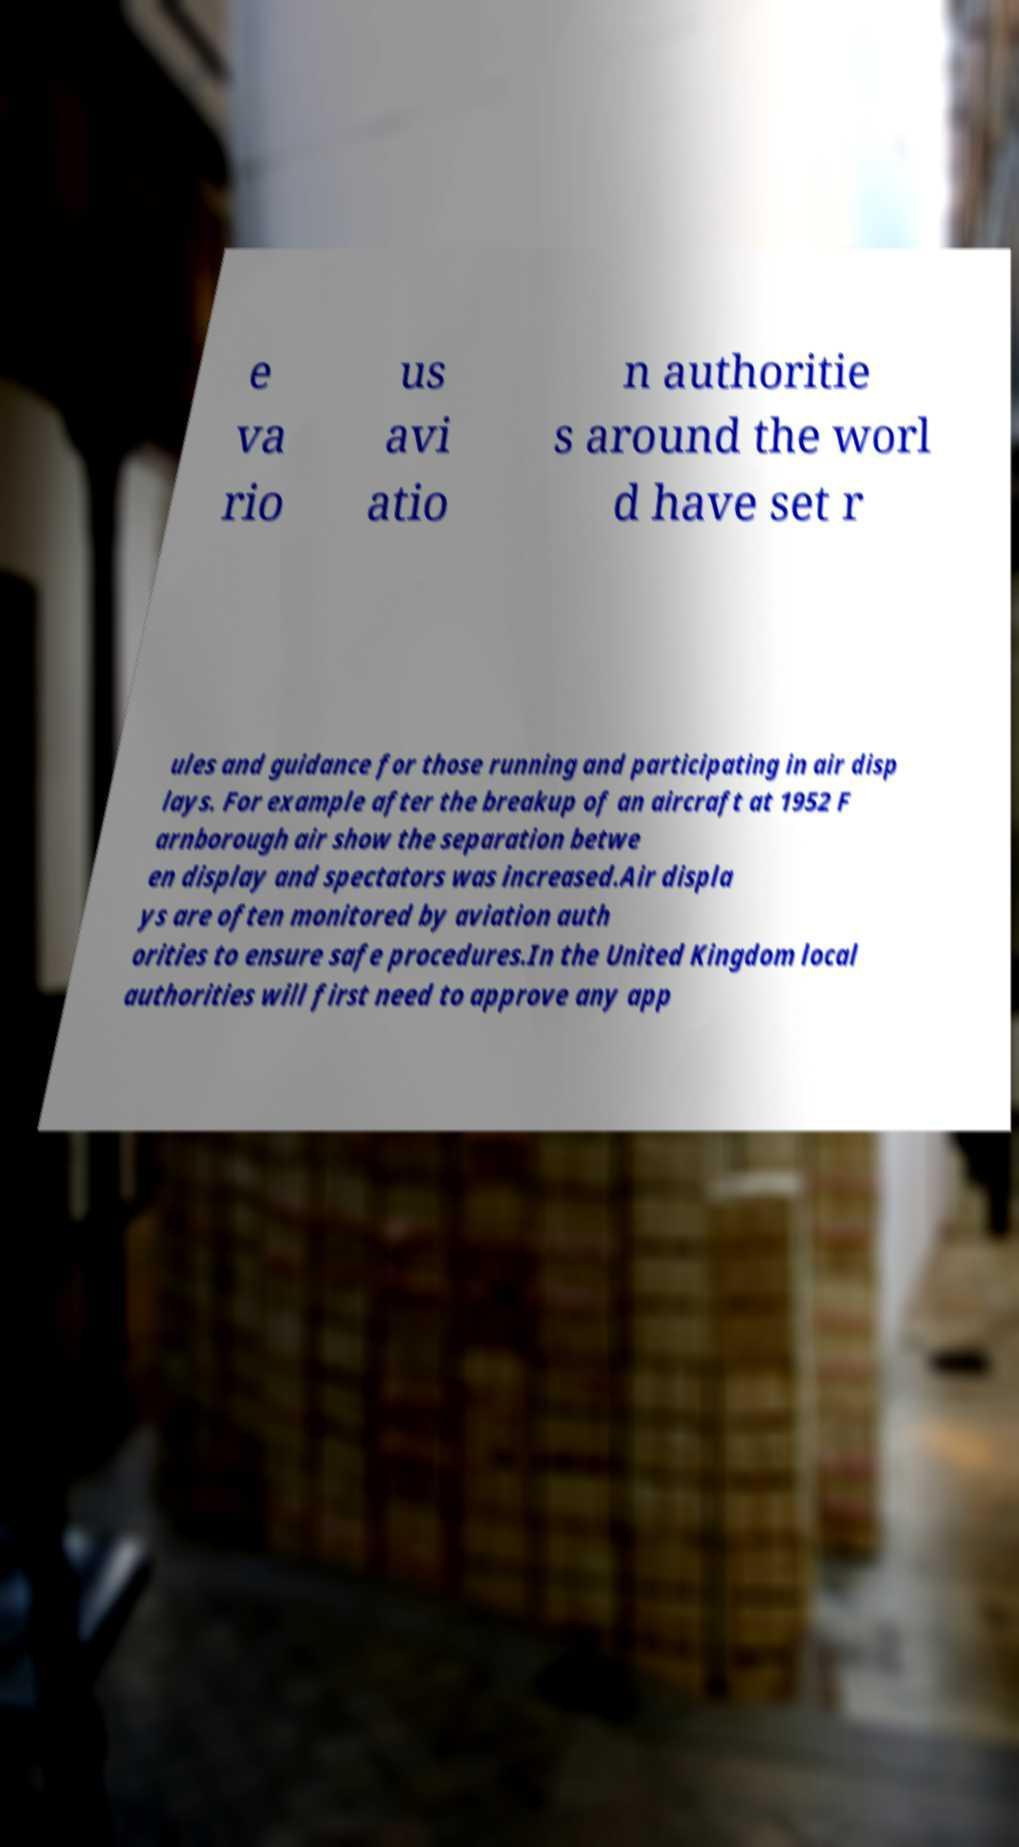Please read and relay the text visible in this image. What does it say? e va rio us avi atio n authoritie s around the worl d have set r ules and guidance for those running and participating in air disp lays. For example after the breakup of an aircraft at 1952 F arnborough air show the separation betwe en display and spectators was increased.Air displa ys are often monitored by aviation auth orities to ensure safe procedures.In the United Kingdom local authorities will first need to approve any app 